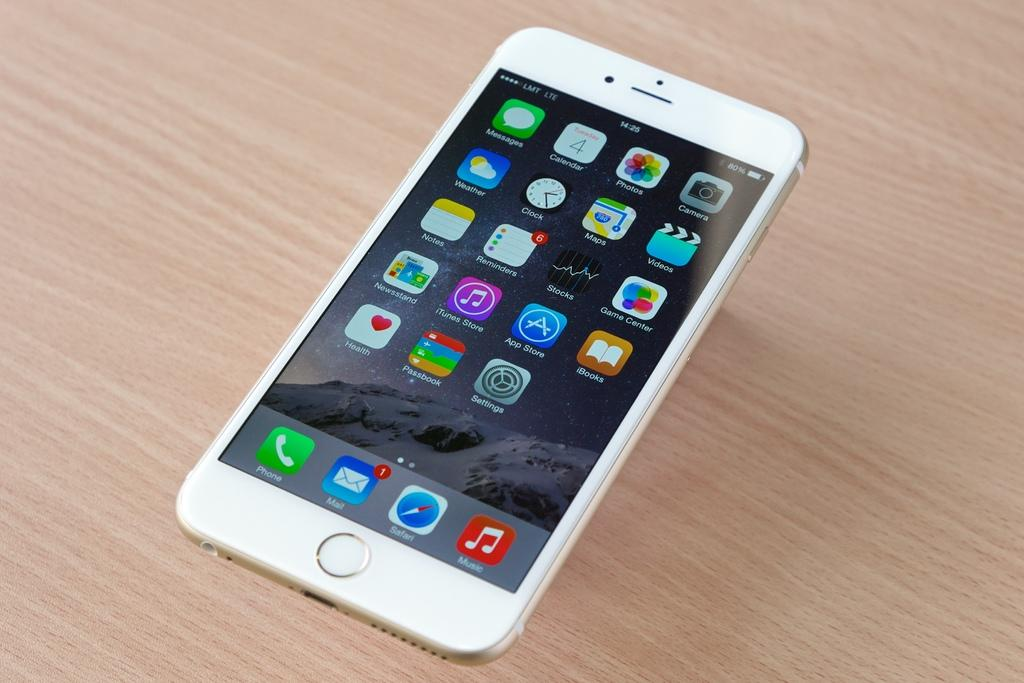Provide a one-sentence caption for the provided image. a white cellphone on the LMT LTE service on a wood table. 